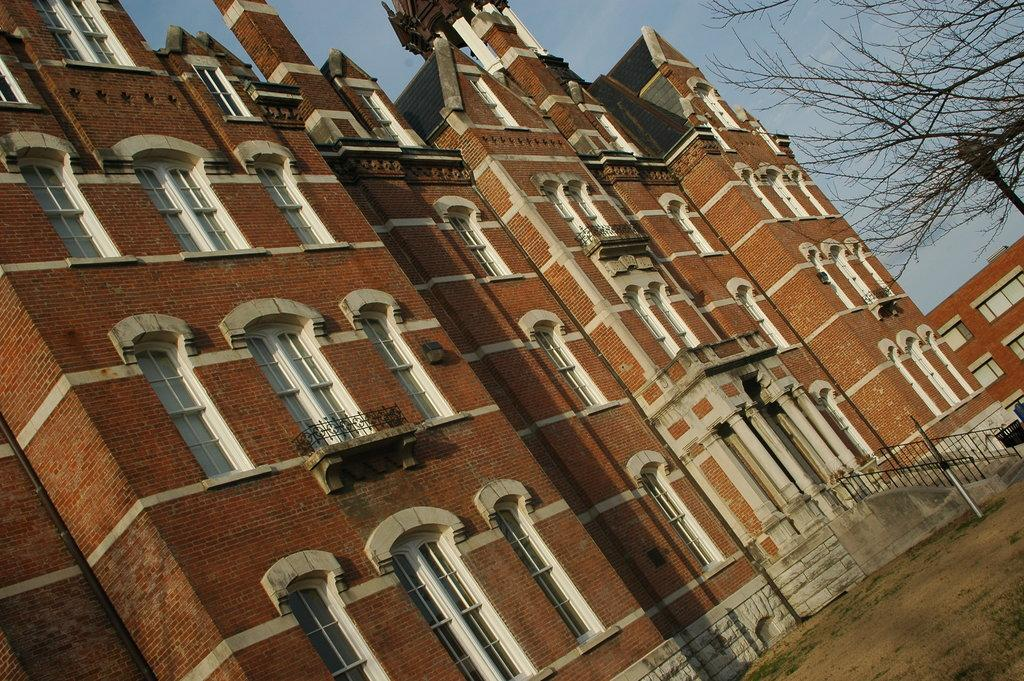What type of building is in the image? There is a big brick building in the image. What architectural feature is present in the image? There are steps in the image. What type of tree is in the image? There is a tree without leaves in the image. What type of force is being applied to the building in the image? There is no force being applied to the building in the image; it is a static structure. 